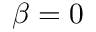<formula> <loc_0><loc_0><loc_500><loc_500>\beta = 0</formula> 